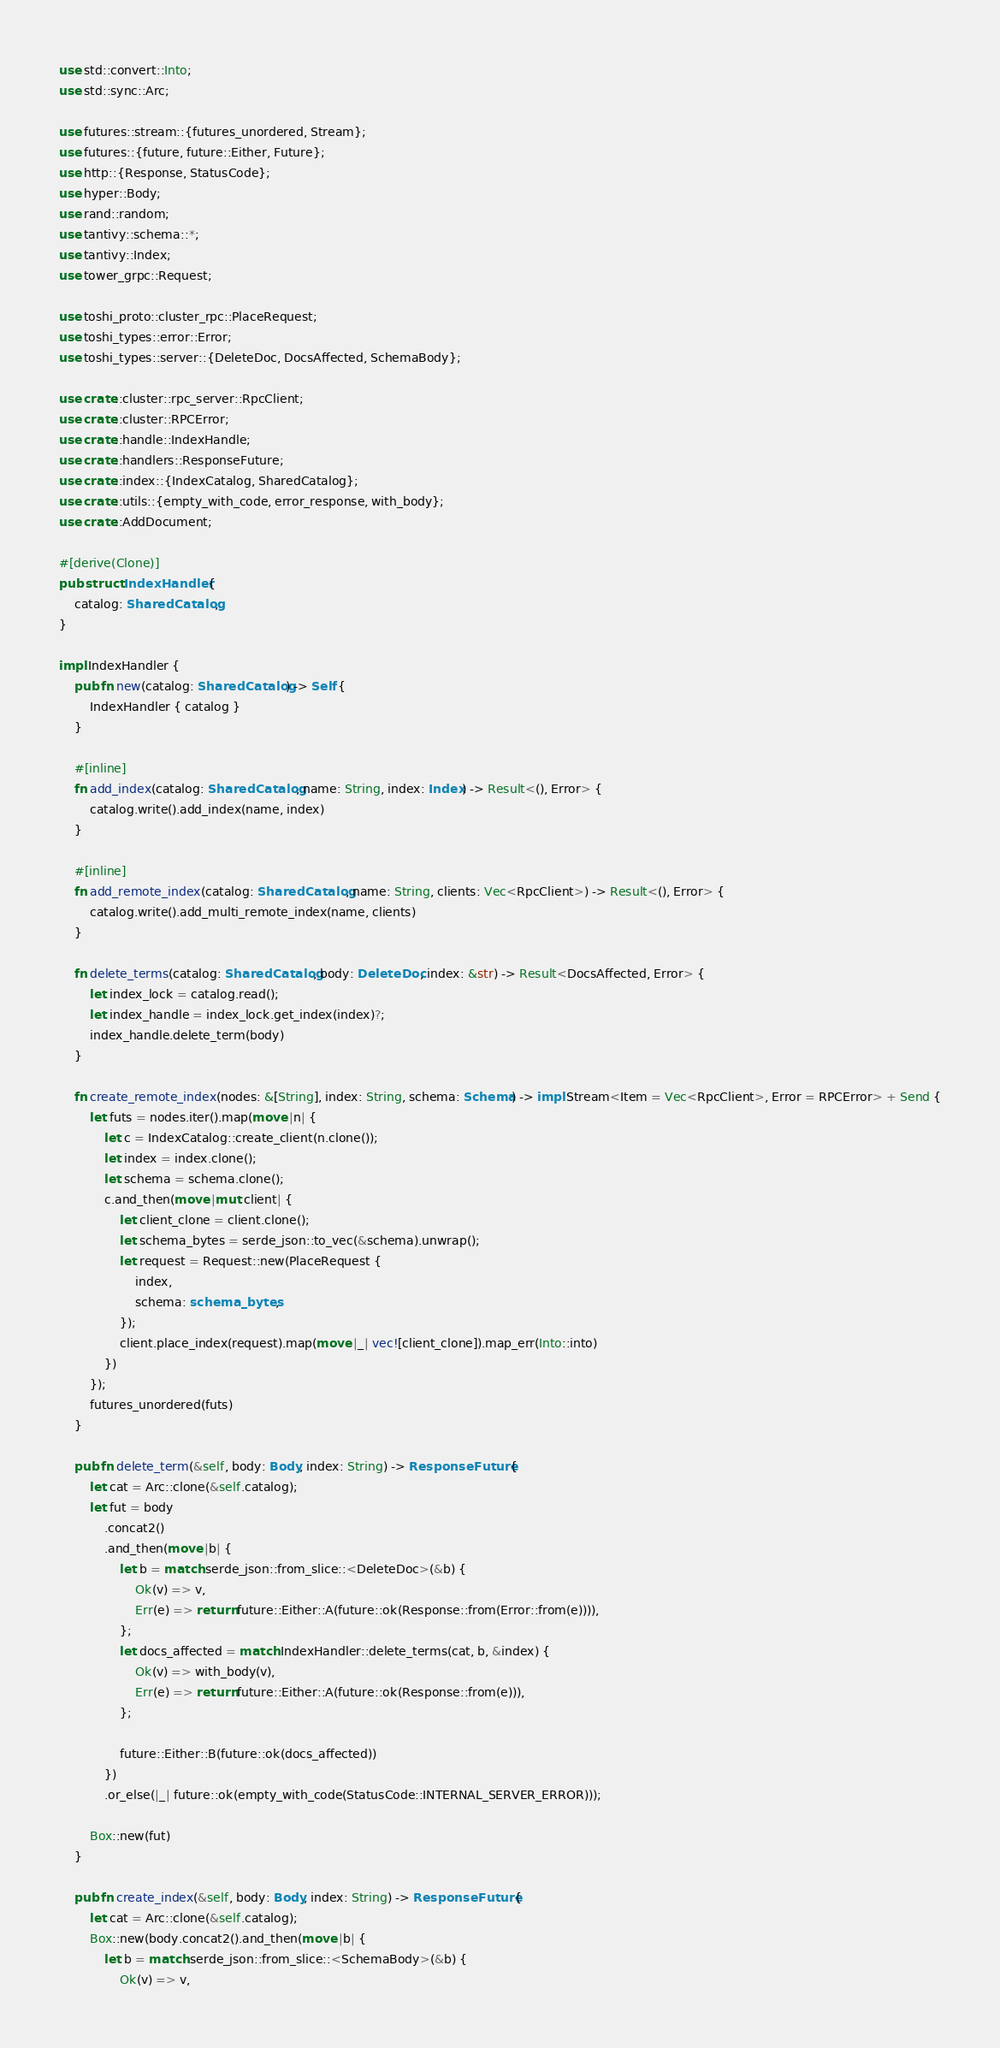Convert code to text. <code><loc_0><loc_0><loc_500><loc_500><_Rust_>use std::convert::Into;
use std::sync::Arc;

use futures::stream::{futures_unordered, Stream};
use futures::{future, future::Either, Future};
use http::{Response, StatusCode};
use hyper::Body;
use rand::random;
use tantivy::schema::*;
use tantivy::Index;
use tower_grpc::Request;

use toshi_proto::cluster_rpc::PlaceRequest;
use toshi_types::error::Error;
use toshi_types::server::{DeleteDoc, DocsAffected, SchemaBody};

use crate::cluster::rpc_server::RpcClient;
use crate::cluster::RPCError;
use crate::handle::IndexHandle;
use crate::handlers::ResponseFuture;
use crate::index::{IndexCatalog, SharedCatalog};
use crate::utils::{empty_with_code, error_response, with_body};
use crate::AddDocument;

#[derive(Clone)]
pub struct IndexHandler {
    catalog: SharedCatalog,
}

impl IndexHandler {
    pub fn new(catalog: SharedCatalog) -> Self {
        IndexHandler { catalog }
    }

    #[inline]
    fn add_index(catalog: SharedCatalog, name: String, index: Index) -> Result<(), Error> {
        catalog.write().add_index(name, index)
    }

    #[inline]
    fn add_remote_index(catalog: SharedCatalog, name: String, clients: Vec<RpcClient>) -> Result<(), Error> {
        catalog.write().add_multi_remote_index(name, clients)
    }

    fn delete_terms(catalog: SharedCatalog, body: DeleteDoc, index: &str) -> Result<DocsAffected, Error> {
        let index_lock = catalog.read();
        let index_handle = index_lock.get_index(index)?;
        index_handle.delete_term(body)
    }

    fn create_remote_index(nodes: &[String], index: String, schema: Schema) -> impl Stream<Item = Vec<RpcClient>, Error = RPCError> + Send {
        let futs = nodes.iter().map(move |n| {
            let c = IndexCatalog::create_client(n.clone());
            let index = index.clone();
            let schema = schema.clone();
            c.and_then(move |mut client| {
                let client_clone = client.clone();
                let schema_bytes = serde_json::to_vec(&schema).unwrap();
                let request = Request::new(PlaceRequest {
                    index,
                    schema: schema_bytes,
                });
                client.place_index(request).map(move |_| vec![client_clone]).map_err(Into::into)
            })
        });
        futures_unordered(futs)
    }

    pub fn delete_term(&self, body: Body, index: String) -> ResponseFuture {
        let cat = Arc::clone(&self.catalog);
        let fut = body
            .concat2()
            .and_then(move |b| {
                let b = match serde_json::from_slice::<DeleteDoc>(&b) {
                    Ok(v) => v,
                    Err(e) => return future::Either::A(future::ok(Response::from(Error::from(e)))),
                };
                let docs_affected = match IndexHandler::delete_terms(cat, b, &index) {
                    Ok(v) => with_body(v),
                    Err(e) => return future::Either::A(future::ok(Response::from(e))),
                };

                future::Either::B(future::ok(docs_affected))
            })
            .or_else(|_| future::ok(empty_with_code(StatusCode::INTERNAL_SERVER_ERROR)));

        Box::new(fut)
    }

    pub fn create_index(&self, body: Body, index: String) -> ResponseFuture {
        let cat = Arc::clone(&self.catalog);
        Box::new(body.concat2().and_then(move |b| {
            let b = match serde_json::from_slice::<SchemaBody>(&b) {
                Ok(v) => v,</code> 